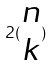Convert formula to latex. <formula><loc_0><loc_0><loc_500><loc_500>2 ( \begin{matrix} n \\ k \end{matrix} )</formula> 